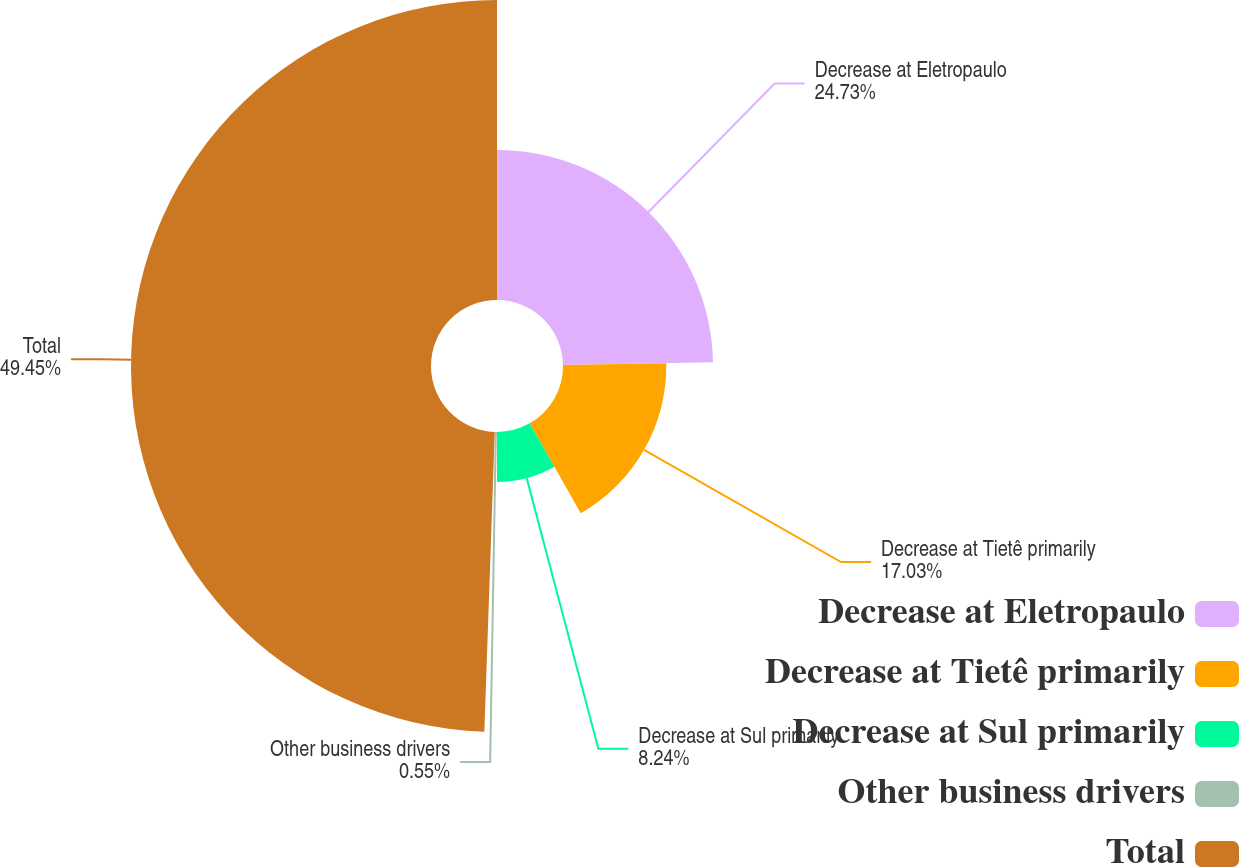Convert chart. <chart><loc_0><loc_0><loc_500><loc_500><pie_chart><fcel>Decrease at Eletropaulo<fcel>Decrease at Tietê primarily<fcel>Decrease at Sul primarily<fcel>Other business drivers<fcel>Total<nl><fcel>24.73%<fcel>17.03%<fcel>8.24%<fcel>0.55%<fcel>49.45%<nl></chart> 